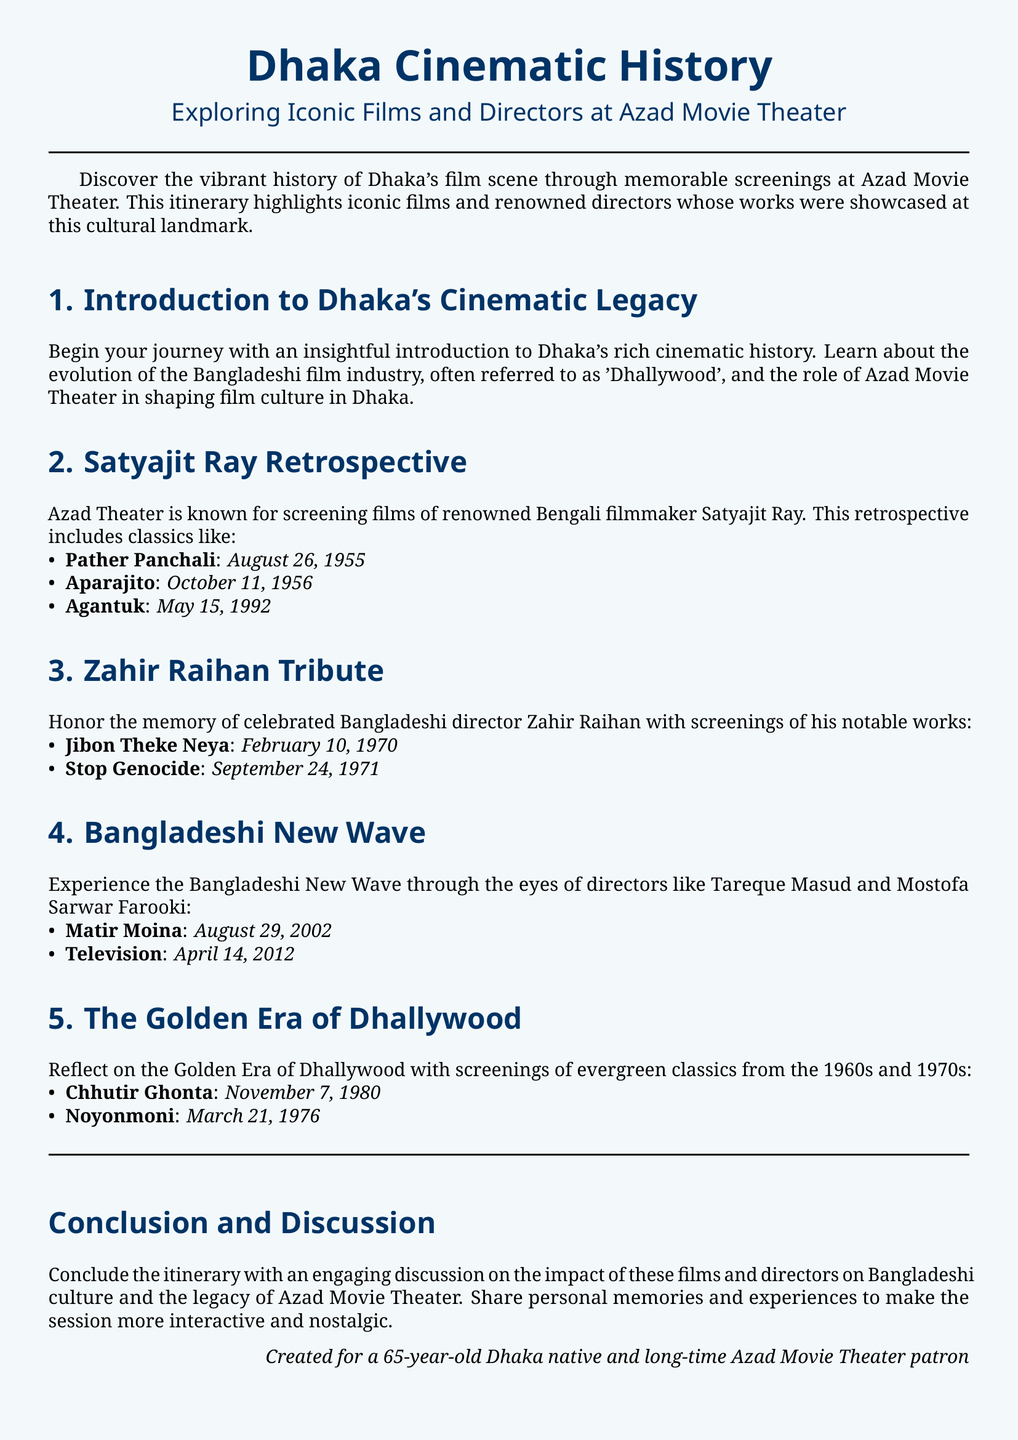What year was "Pather Panchali" screened? The screening date is mentioned as August 26, 1955 in the document.
Answer: August 26, 1955 Who directed "Matir Moina"? The document states that it was directed by Tareque Masud under the Bangladeshi New Wave section.
Answer: Tareque Masud What notable work was screened on September 24, 1971? The document specifies "Stop Genocide" as the film screened on this date.
Answer: Stop Genocide Which era does the film "Noyonmoni" belong to? The document indicates it is part of the Golden Era of Dhallywood as mentioned in the relevant section.
Answer: Golden Era of Dhallywood What is the purpose of the concluding section of the itinerary? The conclusion encourages discussion about the impact of the films and directors on Bangladeshi culture.
Answer: Discussion How many films by Satyajit Ray are mentioned in the itinerary? The document lists three films under the Satyajit Ray Retrospective section.
Answer: Three What is the focus of the second section? The focus is on Satyajit Ray and his retrospective films at Azad Theater.
Answer: Satyajit Ray Retrospective When was the tribute to Zahir Raihan held? The document specifies the tribute through screenings took place on February 10, 1970 and September 24, 1971.
Answer: February 10, 1970; September 24, 1971 